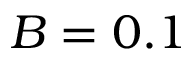<formula> <loc_0><loc_0><loc_500><loc_500>B = 0 . 1</formula> 